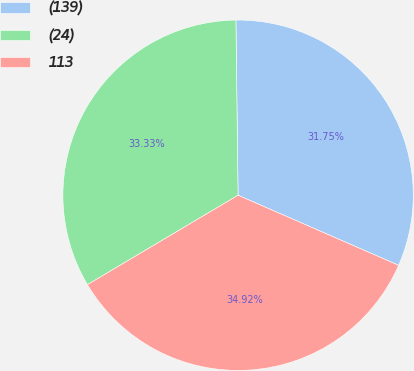Convert chart. <chart><loc_0><loc_0><loc_500><loc_500><pie_chart><fcel>(139)<fcel>(24)<fcel>113<nl><fcel>31.75%<fcel>33.33%<fcel>34.92%<nl></chart> 